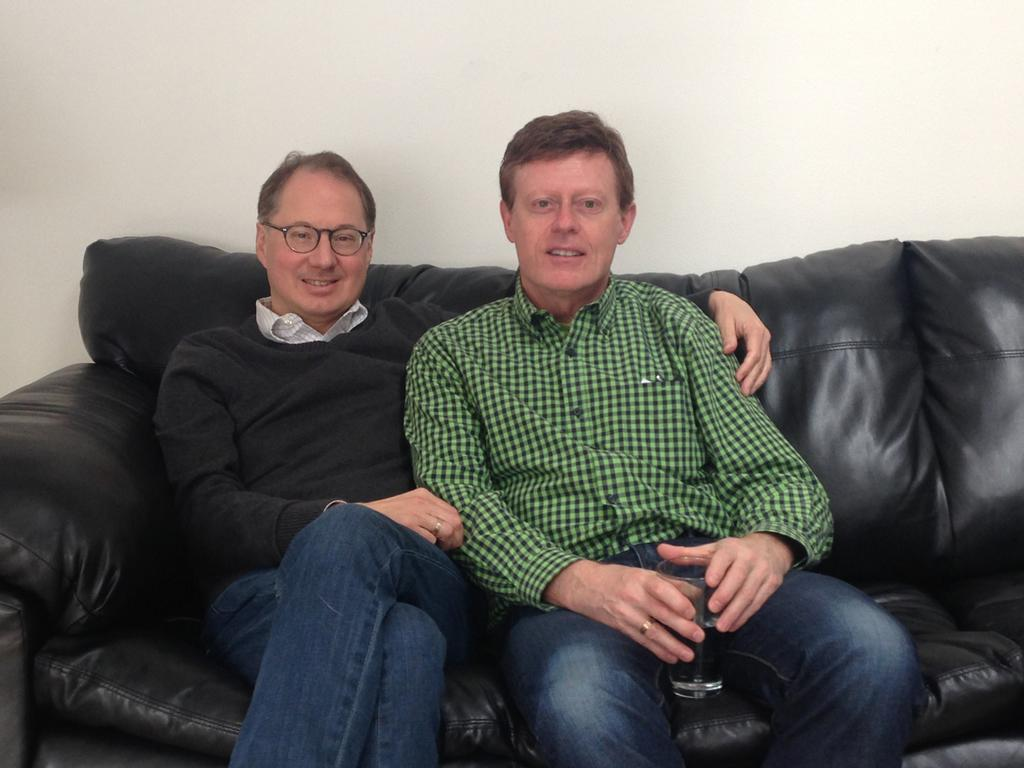How many people are present in the image? There are two people in the image. What are the people doing in the image? The people are sitting on a sofa. Can you describe the clothing of one of the individuals? One person is wearing a green color shirt. What is the person wearing the green color shirt holding? The person wearing the green color shirt is holding a glass. What can be seen in the background of the image? There is a wall in the background of the image. What type of songs can be heard playing in the background of the image? There is no indication of any music or songs being played in the image, as it only shows two people sitting on a sofa. 